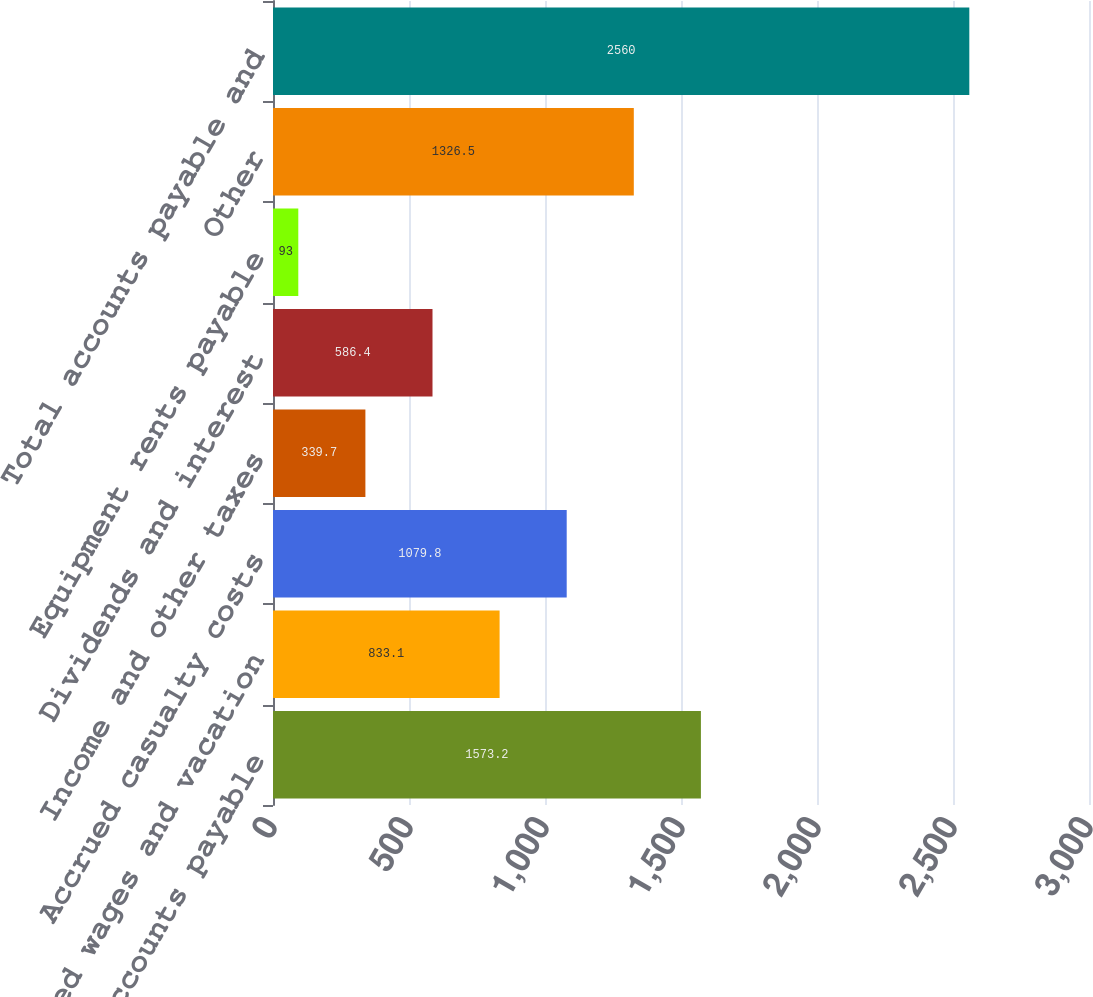Convert chart. <chart><loc_0><loc_0><loc_500><loc_500><bar_chart><fcel>Accounts payable<fcel>Accrued wages and vacation<fcel>Accrued casualty costs<fcel>Income and other taxes<fcel>Dividends and interest<fcel>Equipment rents payable<fcel>Other<fcel>Total accounts payable and<nl><fcel>1573.2<fcel>833.1<fcel>1079.8<fcel>339.7<fcel>586.4<fcel>93<fcel>1326.5<fcel>2560<nl></chart> 